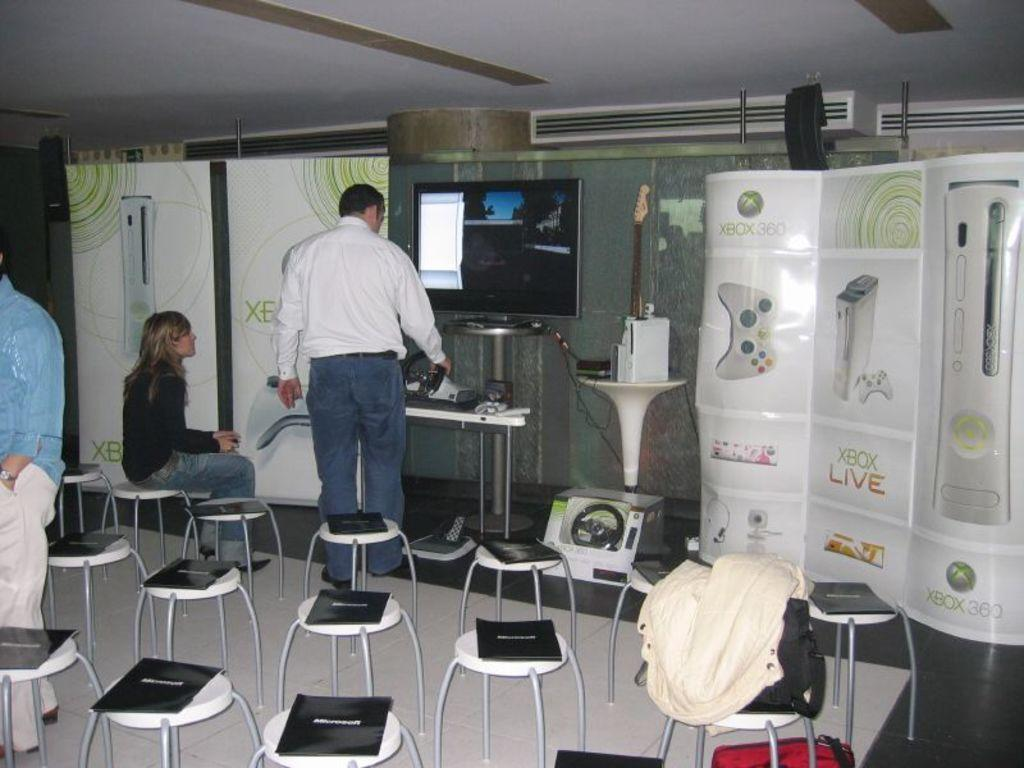<image>
Relay a brief, clear account of the picture shown. A meeting space has a large XBOX banner set up in front. 